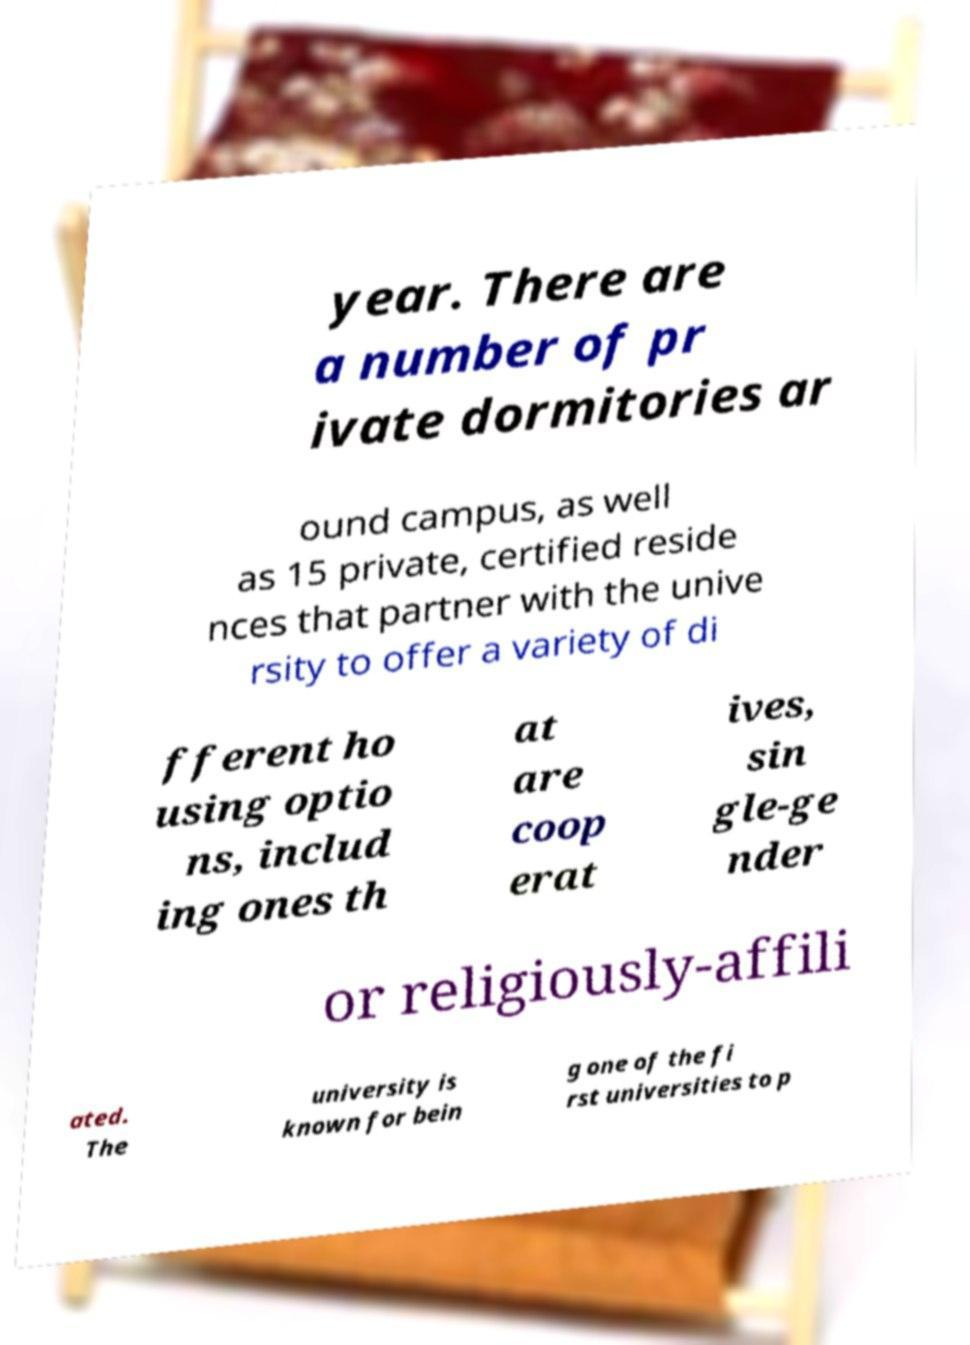Can you read and provide the text displayed in the image?This photo seems to have some interesting text. Can you extract and type it out for me? year. There are a number of pr ivate dormitories ar ound campus, as well as 15 private, certified reside nces that partner with the unive rsity to offer a variety of di fferent ho using optio ns, includ ing ones th at are coop erat ives, sin gle-ge nder or religiously-affili ated. The university is known for bein g one of the fi rst universities to p 